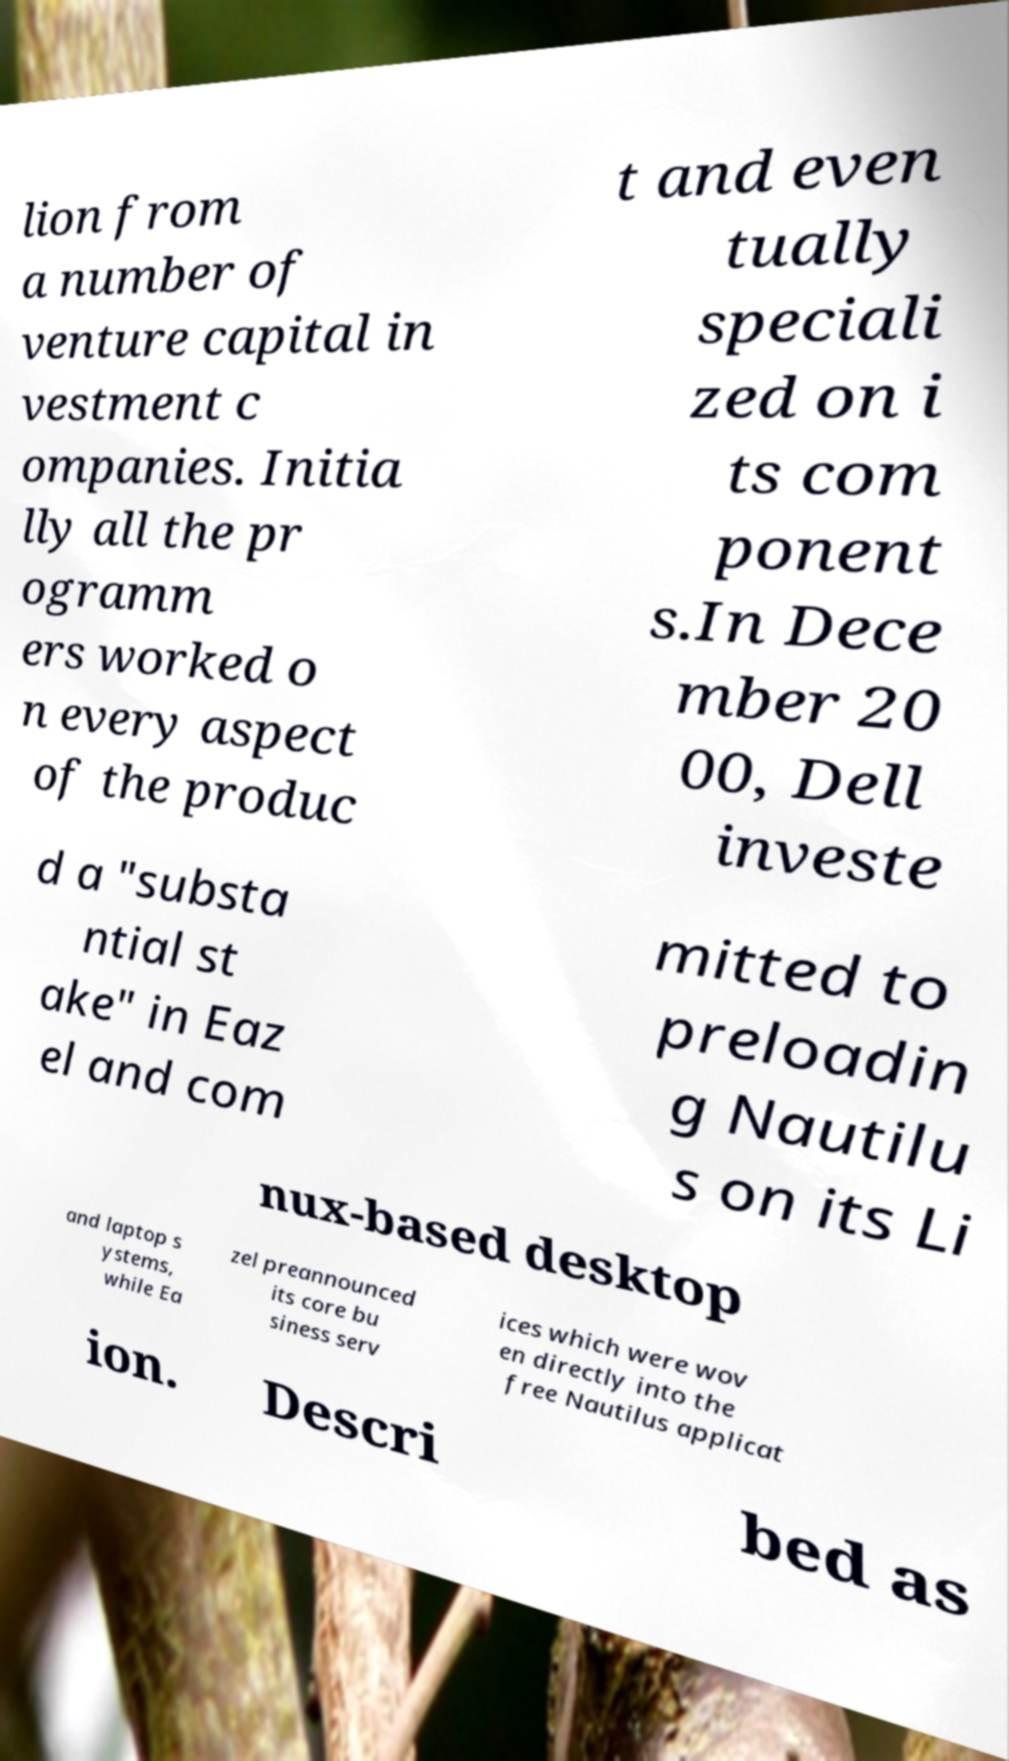Could you assist in decoding the text presented in this image and type it out clearly? lion from a number of venture capital in vestment c ompanies. Initia lly all the pr ogramm ers worked o n every aspect of the produc t and even tually speciali zed on i ts com ponent s.In Dece mber 20 00, Dell investe d a "substa ntial st ake" in Eaz el and com mitted to preloadin g Nautilu s on its Li nux-based desktop and laptop s ystems, while Ea zel preannounced its core bu siness serv ices which were wov en directly into the free Nautilus applicat ion. Descri bed as 